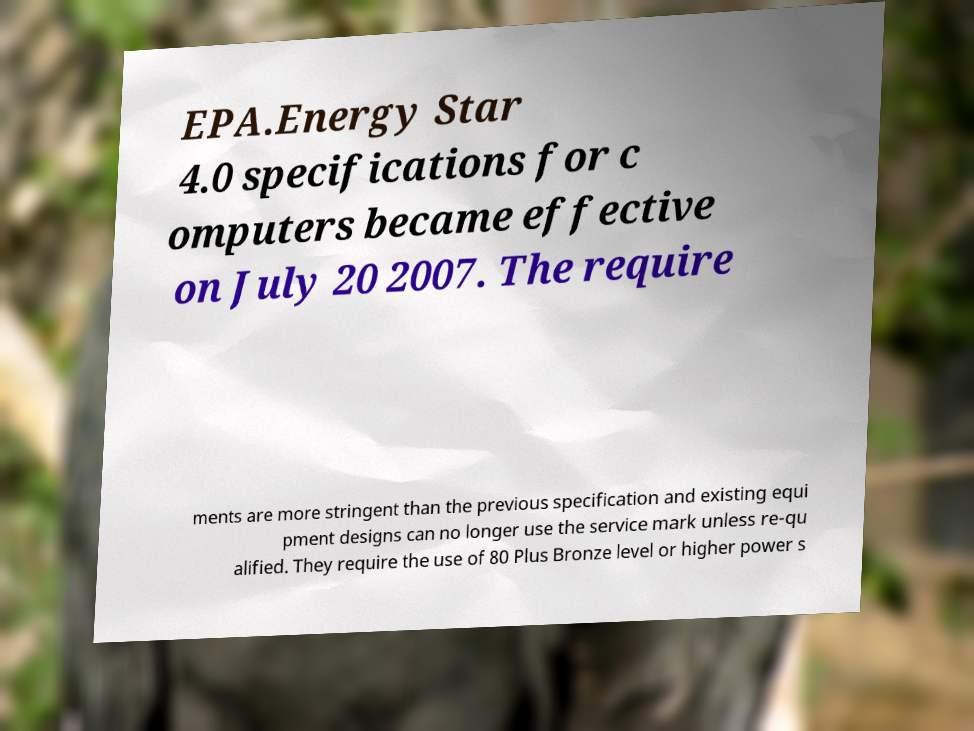Please read and relay the text visible in this image. What does it say? EPA.Energy Star 4.0 specifications for c omputers became effective on July 20 2007. The require ments are more stringent than the previous specification and existing equi pment designs can no longer use the service mark unless re-qu alified. They require the use of 80 Plus Bronze level or higher power s 